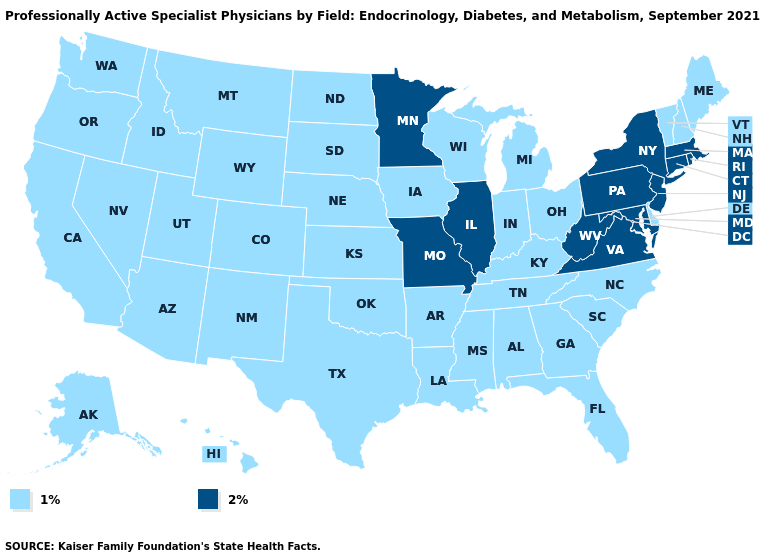Does Connecticut have a higher value than Maryland?
Short answer required. No. What is the value of Virginia?
Concise answer only. 2%. Does the first symbol in the legend represent the smallest category?
Be succinct. Yes. What is the value of Maryland?
Write a very short answer. 2%. Is the legend a continuous bar?
Answer briefly. No. Name the states that have a value in the range 2%?
Short answer required. Connecticut, Illinois, Maryland, Massachusetts, Minnesota, Missouri, New Jersey, New York, Pennsylvania, Rhode Island, Virginia, West Virginia. Which states hav the highest value in the Northeast?
Short answer required. Connecticut, Massachusetts, New Jersey, New York, Pennsylvania, Rhode Island. What is the value of West Virginia?
Keep it brief. 2%. Which states have the lowest value in the USA?
Give a very brief answer. Alabama, Alaska, Arizona, Arkansas, California, Colorado, Delaware, Florida, Georgia, Hawaii, Idaho, Indiana, Iowa, Kansas, Kentucky, Louisiana, Maine, Michigan, Mississippi, Montana, Nebraska, Nevada, New Hampshire, New Mexico, North Carolina, North Dakota, Ohio, Oklahoma, Oregon, South Carolina, South Dakota, Tennessee, Texas, Utah, Vermont, Washington, Wisconsin, Wyoming. Name the states that have a value in the range 1%?
Quick response, please. Alabama, Alaska, Arizona, Arkansas, California, Colorado, Delaware, Florida, Georgia, Hawaii, Idaho, Indiana, Iowa, Kansas, Kentucky, Louisiana, Maine, Michigan, Mississippi, Montana, Nebraska, Nevada, New Hampshire, New Mexico, North Carolina, North Dakota, Ohio, Oklahoma, Oregon, South Carolina, South Dakota, Tennessee, Texas, Utah, Vermont, Washington, Wisconsin, Wyoming. Which states have the highest value in the USA?
Keep it brief. Connecticut, Illinois, Maryland, Massachusetts, Minnesota, Missouri, New Jersey, New York, Pennsylvania, Rhode Island, Virginia, West Virginia. Which states hav the highest value in the West?
Give a very brief answer. Alaska, Arizona, California, Colorado, Hawaii, Idaho, Montana, Nevada, New Mexico, Oregon, Utah, Washington, Wyoming. What is the value of Arizona?
Give a very brief answer. 1%. 